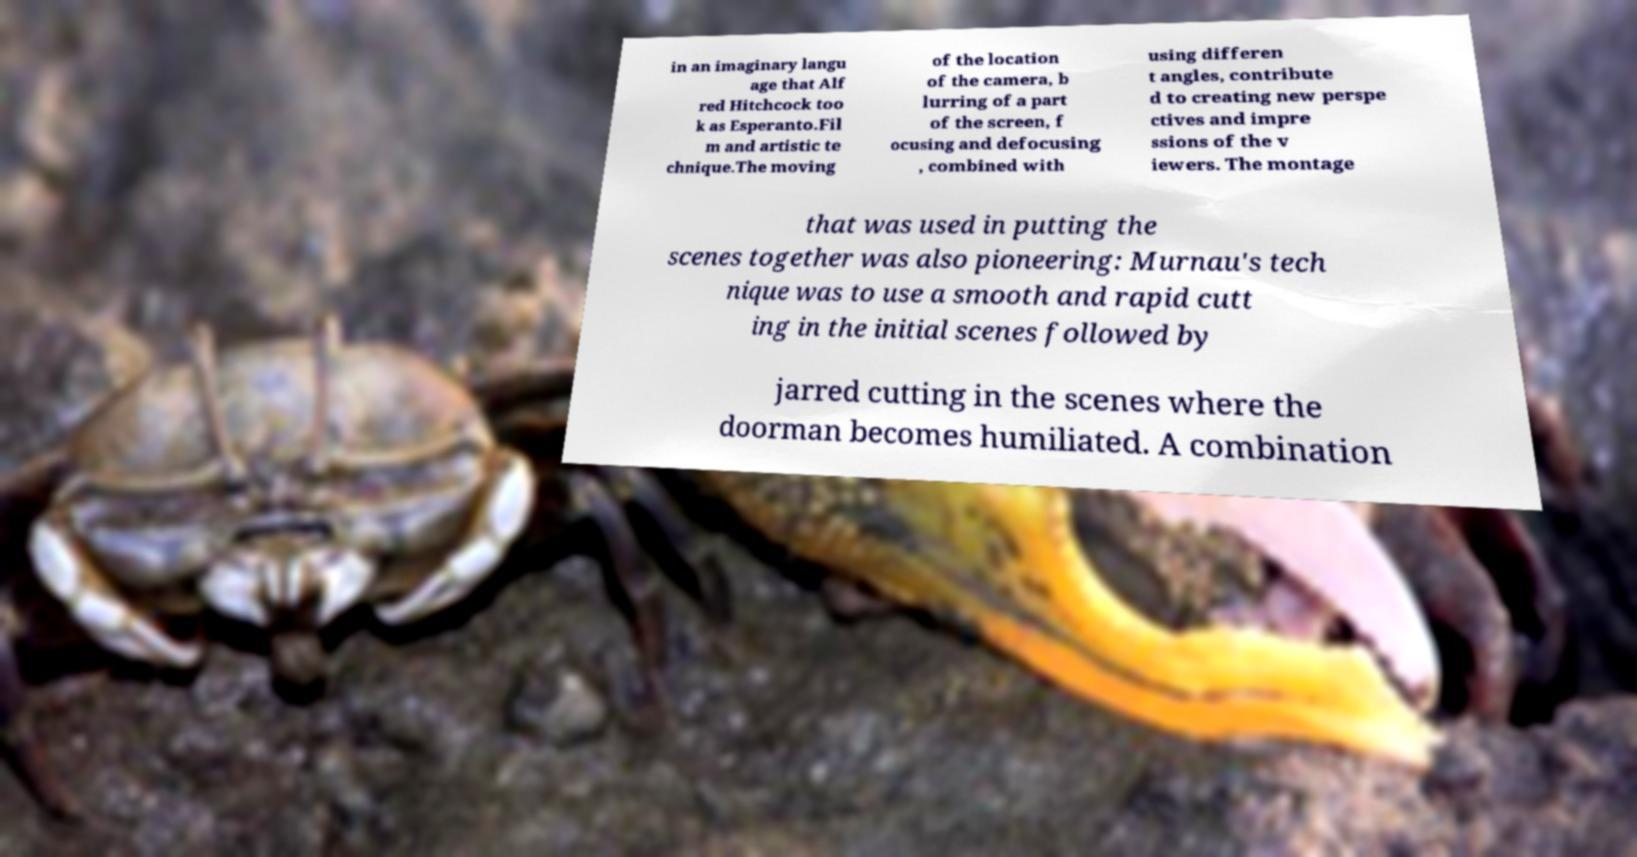Can you accurately transcribe the text from the provided image for me? in an imaginary langu age that Alf red Hitchcock too k as Esperanto.Fil m and artistic te chnique.The moving of the location of the camera, b lurring of a part of the screen, f ocusing and defocusing , combined with using differen t angles, contribute d to creating new perspe ctives and impre ssions of the v iewers. The montage that was used in putting the scenes together was also pioneering: Murnau's tech nique was to use a smooth and rapid cutt ing in the initial scenes followed by jarred cutting in the scenes where the doorman becomes humiliated. A combination 